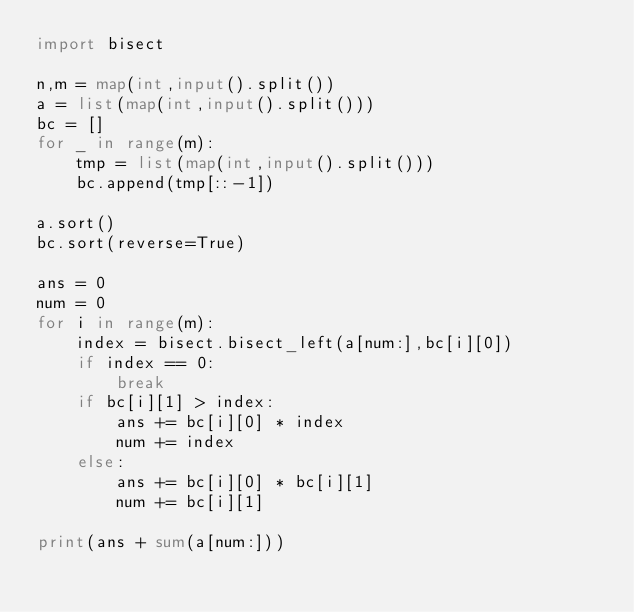<code> <loc_0><loc_0><loc_500><loc_500><_Python_>import bisect

n,m = map(int,input().split())
a = list(map(int,input().split()))
bc = []
for _ in range(m):
    tmp = list(map(int,input().split()))
    bc.append(tmp[::-1])

a.sort()
bc.sort(reverse=True)

ans = 0
num = 0
for i in range(m):
    index = bisect.bisect_left(a[num:],bc[i][0])
    if index == 0:
        break
    if bc[i][1] > index:
        ans += bc[i][0] * index
        num += index
    else:
        ans += bc[i][0] * bc[i][1]
        num += bc[i][1]

print(ans + sum(a[num:]))
</code> 